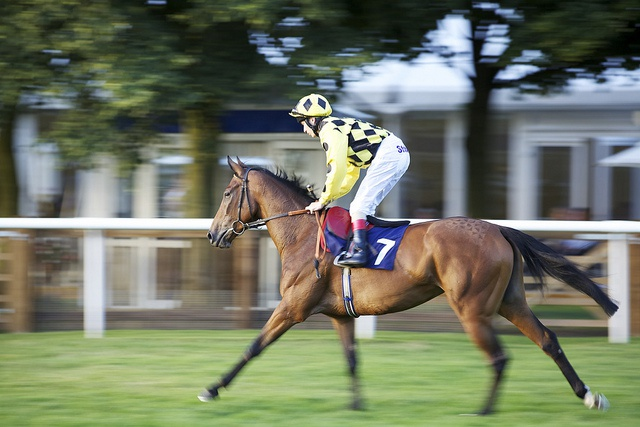Describe the objects in this image and their specific colors. I can see horse in black, gray, and tan tones and people in black, ivory, khaki, and navy tones in this image. 